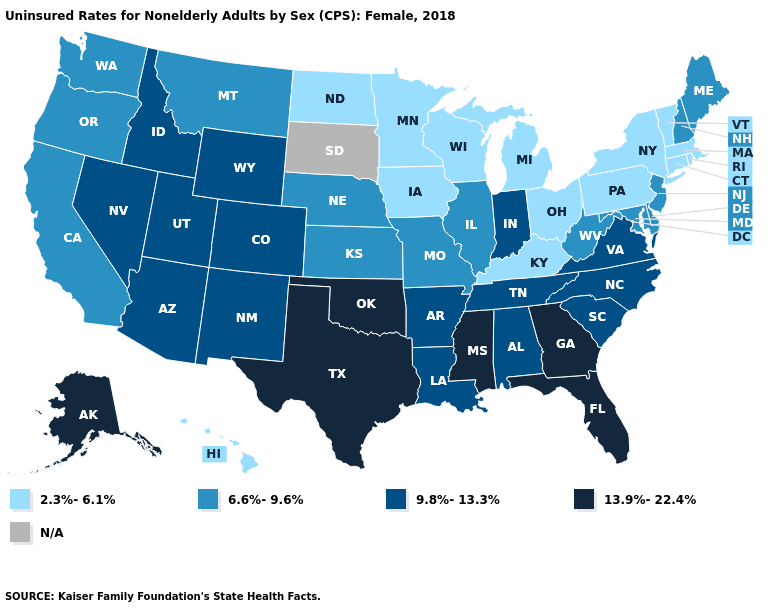What is the value of Wisconsin?
Short answer required. 2.3%-6.1%. Name the states that have a value in the range 13.9%-22.4%?
Give a very brief answer. Alaska, Florida, Georgia, Mississippi, Oklahoma, Texas. Among the states that border Pennsylvania , which have the lowest value?
Write a very short answer. New York, Ohio. What is the value of South Carolina?
Quick response, please. 9.8%-13.3%. What is the value of Wyoming?
Give a very brief answer. 9.8%-13.3%. Name the states that have a value in the range 13.9%-22.4%?
Answer briefly. Alaska, Florida, Georgia, Mississippi, Oklahoma, Texas. What is the value of Texas?
Answer briefly. 13.9%-22.4%. Name the states that have a value in the range 6.6%-9.6%?
Give a very brief answer. California, Delaware, Illinois, Kansas, Maine, Maryland, Missouri, Montana, Nebraska, New Hampshire, New Jersey, Oregon, Washington, West Virginia. What is the value of Kansas?
Be succinct. 6.6%-9.6%. Name the states that have a value in the range 2.3%-6.1%?
Write a very short answer. Connecticut, Hawaii, Iowa, Kentucky, Massachusetts, Michigan, Minnesota, New York, North Dakota, Ohio, Pennsylvania, Rhode Island, Vermont, Wisconsin. What is the highest value in the South ?
Short answer required. 13.9%-22.4%. Name the states that have a value in the range 2.3%-6.1%?
Write a very short answer. Connecticut, Hawaii, Iowa, Kentucky, Massachusetts, Michigan, Minnesota, New York, North Dakota, Ohio, Pennsylvania, Rhode Island, Vermont, Wisconsin. Is the legend a continuous bar?
Concise answer only. No. Name the states that have a value in the range 13.9%-22.4%?
Write a very short answer. Alaska, Florida, Georgia, Mississippi, Oklahoma, Texas. What is the value of Minnesota?
Keep it brief. 2.3%-6.1%. 